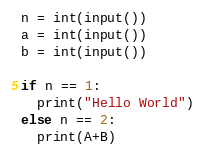<code> <loc_0><loc_0><loc_500><loc_500><_Python_>n = int(input())
a = int(input())
b = int(input())

if n == 1:
  print("Hello World")
else n == 2:
  print(A+B)</code> 